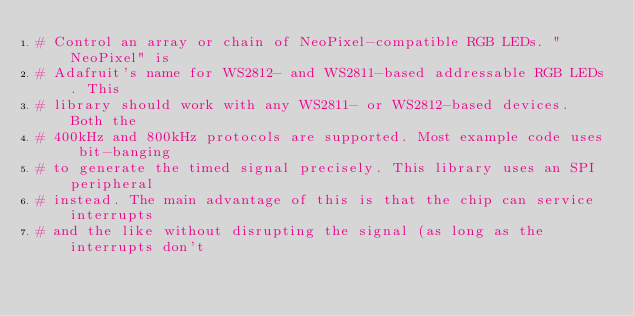<code> <loc_0><loc_0><loc_500><loc_500><_CMake_># Control an array or chain of NeoPixel-compatible RGB LEDs. "NeoPixel" is
# Adafruit's name for WS2812- and WS2811-based addressable RGB LEDs. This
# library should work with any WS2811- or WS2812-based devices. Both the
# 400kHz and 800kHz protocols are supported. Most example code uses bit-banging
# to generate the timed signal precisely. This library uses an SPI peripheral
# instead. The main advantage of this is that the chip can service interrupts
# and the like without disrupting the signal (as long as the interrupts don't</code> 